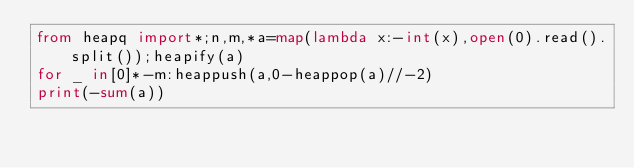Convert code to text. <code><loc_0><loc_0><loc_500><loc_500><_Python_>from heapq import*;n,m,*a=map(lambda x:-int(x),open(0).read().split());heapify(a)
for _ in[0]*-m:heappush(a,0-heappop(a)//-2)
print(-sum(a))</code> 